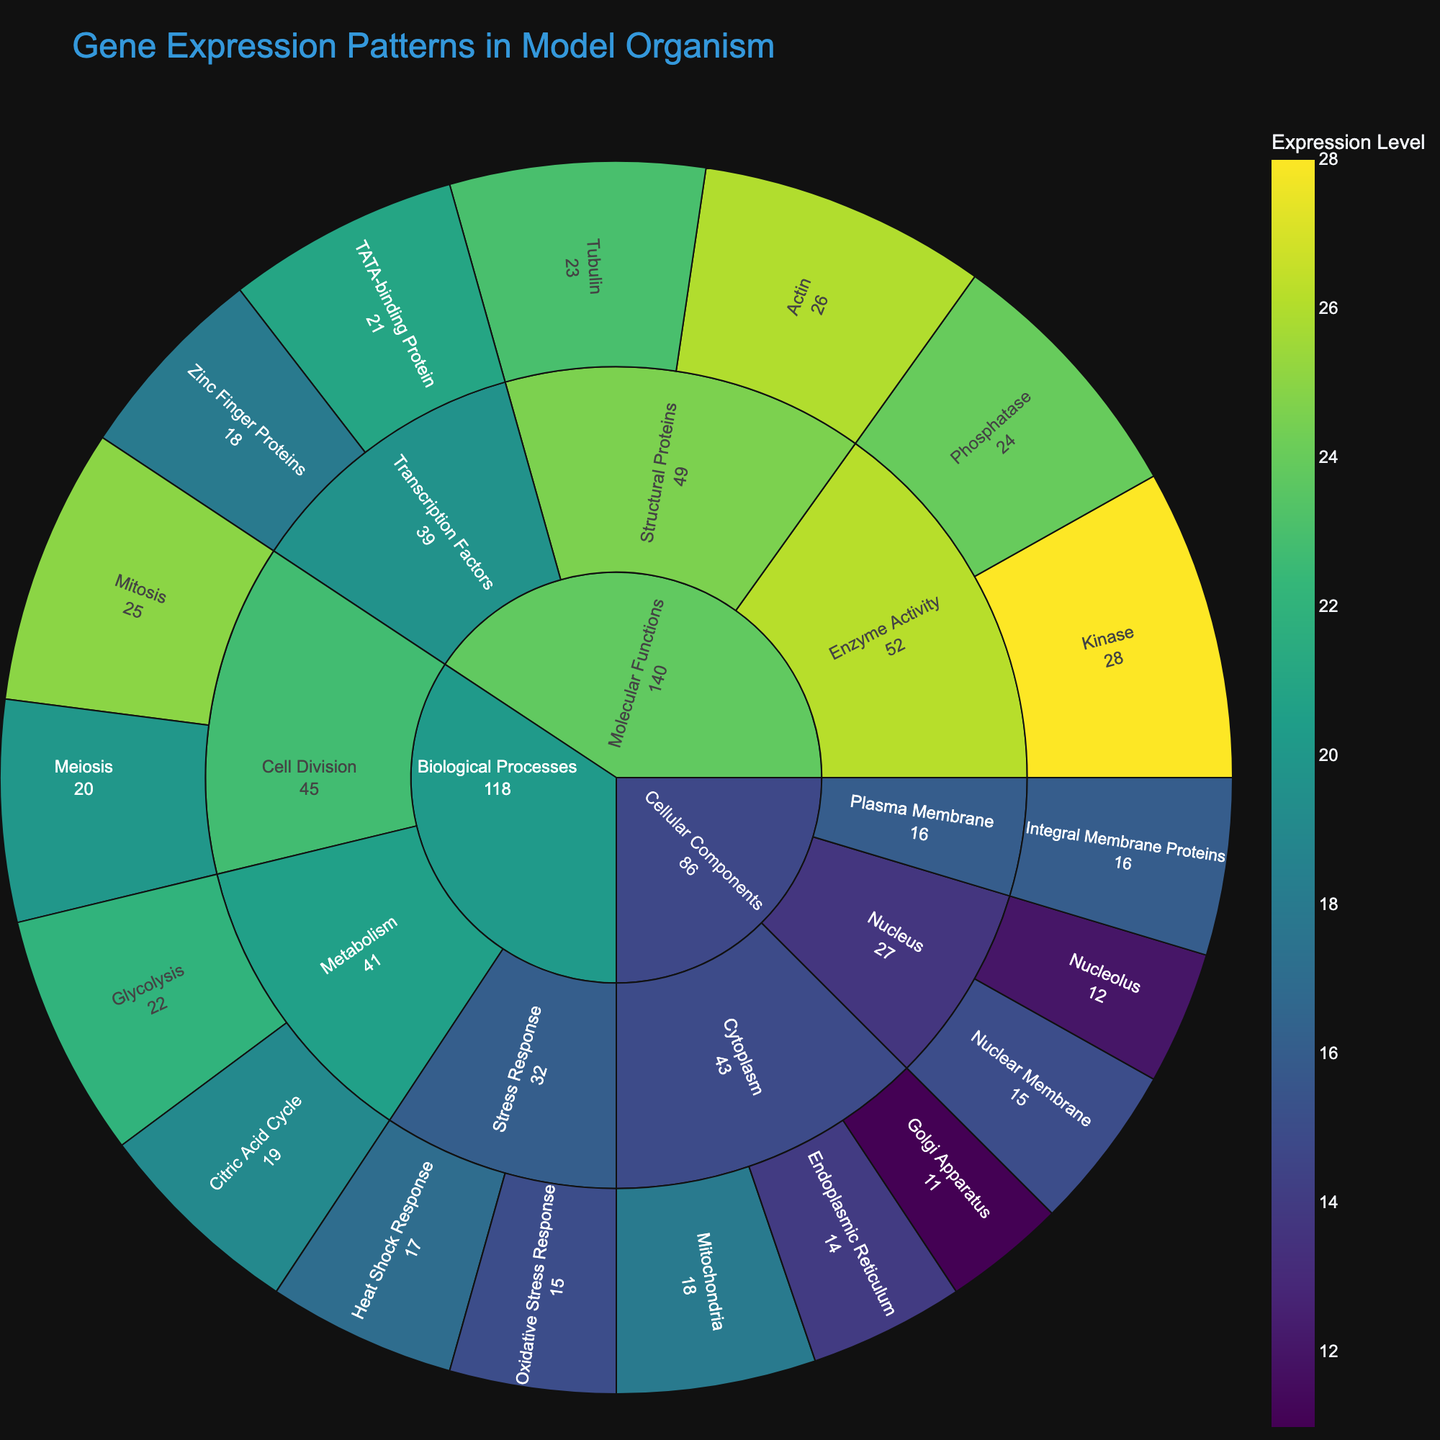How many categories are present in the figure? There are three main categories shown in the sunburst plot: Cellular Components, Biological Processes, and Molecular Functions.
Answer: 3 Which subcategory within Cellular Components has the highest gene expression value? Within the Cellular Components category, Cytoplasm has the highest gene expression value (18 for Mitochondria, 14 for Endoplasmic Reticulum, and 11 for Golgi Apparatus).
Answer: Cytoplasm What is the total gene expression value for Biological Processes? Add the values for all the subcategories and subsubcategories under Biological Processes (Glycolysis: 22, Citric Acid Cycle: 19, Mitosis: 25, Meiosis: 20, Heat Shock Response: 17, Oxidative Stress Response: 15), which sum up to 22 + 19 + 25 + 20 + 17 + 15 = 118.
Answer: 118 Which subsubcategory in Molecular Functions has the lowest gene expression value? In Molecular Functions, among Enzyme Activity (Kinase: 28, Phosphatase: 24), Transcription Factors (TATA-binding Protein: 21, Zinc Finger Proteins: 18), and Structural Proteins (Actin: 26, Tubulin: 23), the lowest value is for Zinc Finger Proteins with 18.
Answer: Zinc Finger Proteins What is the average gene expression value for subcategories within Biological Processes? There are three subcategories: Metabolism (22 + 19 = 41), Cell Division (25 + 20 = 45), and Stress Response (17 + 15 = 32). Average = (41 + 45 + 32) / 3 = 118 / 3 = 39.33.
Answer: 39.33 Which subsubcategory within the Nucleus has a lower gene expression value? In the Nucleus subcategory of Cellular Components, Nuclear Membrane has a value of 15 and Nucleolus has a value of 12. The lower value is for Nucleolus.
Answer: Nucleolus Compare the gene expression values of Metabolism and Cell Division in Biological Processes. Which has a higher total value? Calculate the total values: Metabolism = 22 (Glycolysis) + 19 (Citric Acid Cycle) = 41, and Cell Division = 25 (Mitosis) + 20 (Meiosis) = 45. Cell Division has a higher total value.
Answer: Cell Division What is the sum of gene expression values for all subcategories within Molecular Functions? Add the values for Enzyme Activity (Kinase: 28, Phosphatase: 24), Transcription Factors (TATA-binding Protein: 21, Zinc Finger Proteins: 18), and Structural Proteins (Actin: 26, Tubulin: 23), which sum up to 28 + 24 + 21 + 18 + 26 + 23 = 140.
Answer: 140 How does the gene expression for Integral Membrane Proteins compare to that of Tubulin? The value for Integral Membrane Proteins in Cellular Components is 16, and for Tubulin in Molecular Functions is 23. Tubulin has a higher gene expression value.
Answer: Tubulin Which subcategory has the highest gene expression value within the sunburst plot? Look through all the categories and subcategories to find the highest value. The highest value is 28 for Kinase in the Enzyme Activity subcategory under Molecular Functions.
Answer: Kinase 